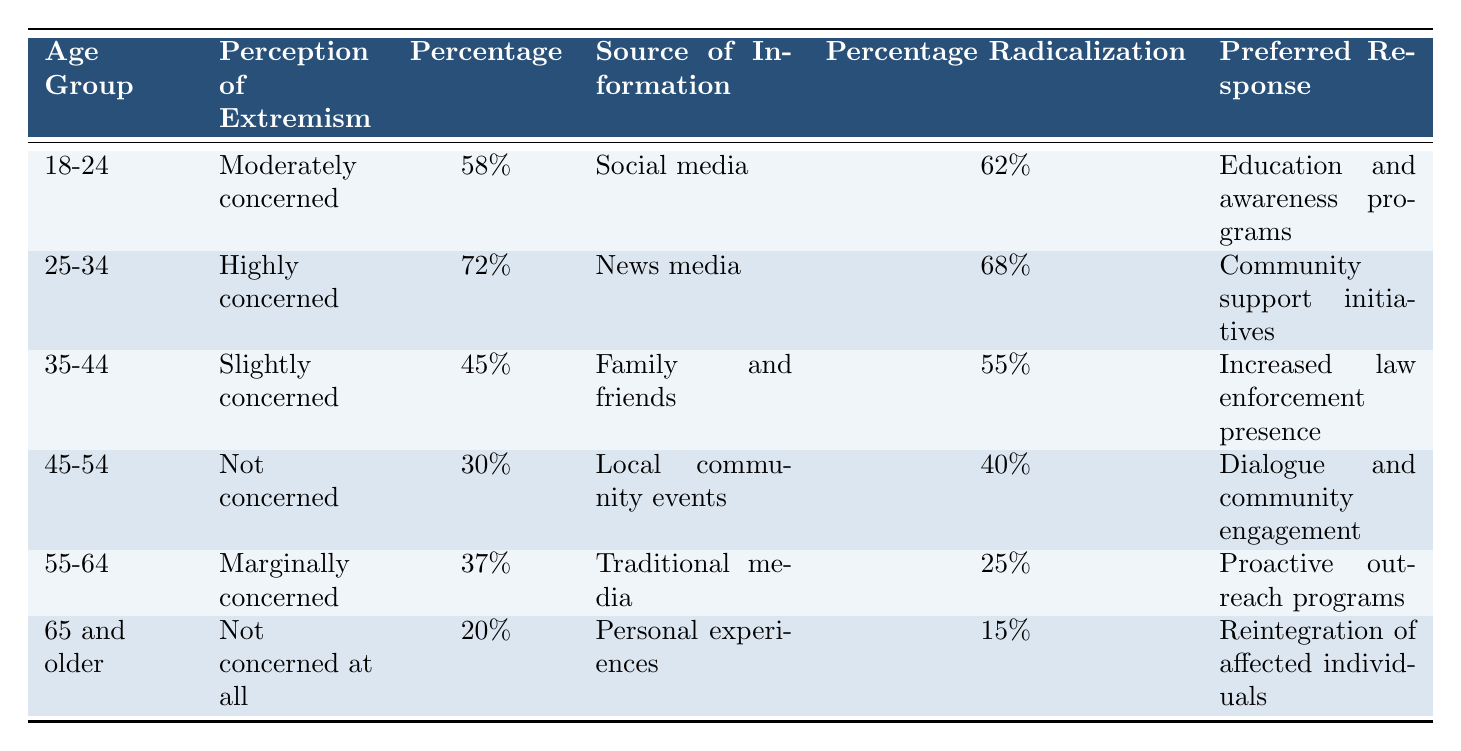What percentage of the 25-34 age group is highly concerned about extremism? According to the table, the 25-34 age group has a perception of extremism labeled as "Highly concerned," and the percentage provided for this age group is 72%.
Answer: 72% What was the primary source of information for the 35-44 age group? The table lists "Family and friends" as the source of information for the 35-44 age group.
Answer: Family and friends How many age groups have a perception of extremism that is categorized as not concerned? There are two age groups in the table with the perception of extremism categorized as "Not concerned," which are the 45-54 age group and the 65 and older age group.
Answer: 2 What is the difference in percentage between the belief in radicalization for the 18-24 and 55-64 age groups? For the 18-24 age group, the belief in radicalization percentage is 62%, and for the 55-64 age group, it is 25%. Thus, the difference is 62% - 25% = 37%.
Answer: 37% Which age group prefers education and awareness programs as their preferred response? The 18-24 age group lists "Education and awareness programs" as their preferred response.
Answer: 18-24 Is it true that the 65 and older age group strongly believes in radicalization? The table states that the 65 and older age group has a belief in radicalization labeled as "Strongly not believe," which indicates that it is false that they strongly believe.
Answer: No What is the average percentage of concern across all age groups regarding extremism? The percentages of concern are 58%, 72%, 45%, 30%, 37%, and 20%. Adding these gives 262%, and dividing by 6 age groups gives an average of 43.67%.
Answer: 43.67% What percentage of the 45-54 age group believes in radicalization? The table indicates that the belief in radicalization for the 45-54 age group is 40%.
Answer: 40% Which age group has the highest concern about extremism, and what is that percentage? The data shows that the 25-34 age group has the highest concern about extremism at 72%.
Answer: 25-34, 72% How many age groups have a perception of extremism that is classified as "Marginally concerned" or better? The age groups classified as "Moderately concerned," "Highly concerned," and "Marginally concerned" are the 18-24, 25-34, and 55-64 age groups. This makes it three groups that are classified as "Marginally concerned" or better.
Answer: 3 What is the preferred response for the 65 and older age group? The preferred response for the 65 and older age group is "Reintegration of affected individuals."
Answer: Reintegration of affected individuals 